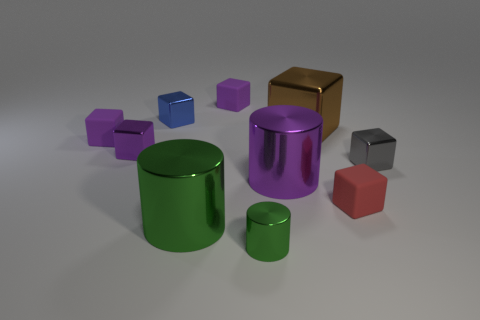There is a cylinder behind the red thing; does it have the same size as the gray object?
Give a very brief answer. No. How many things are behind the small green metal thing?
Give a very brief answer. 9. Is there a brown matte ball that has the same size as the red block?
Make the answer very short. No. Does the big cube have the same color as the tiny metal cylinder?
Provide a short and direct response. No. What color is the large shiny cylinder that is in front of the rubber object that is in front of the purple cylinder?
Offer a terse response. Green. How many tiny blocks are right of the blue block and on the left side of the brown object?
Your answer should be very brief. 1. How many tiny rubber things have the same shape as the small purple metal thing?
Make the answer very short. 3. Is the material of the brown object the same as the tiny green cylinder?
Provide a succinct answer. Yes. What shape is the rubber object that is in front of the purple metal object that is behind the gray cube?
Offer a terse response. Cube. There is a small matte thing left of the small blue shiny thing; how many big brown shiny things are on the right side of it?
Your response must be concise. 1. 